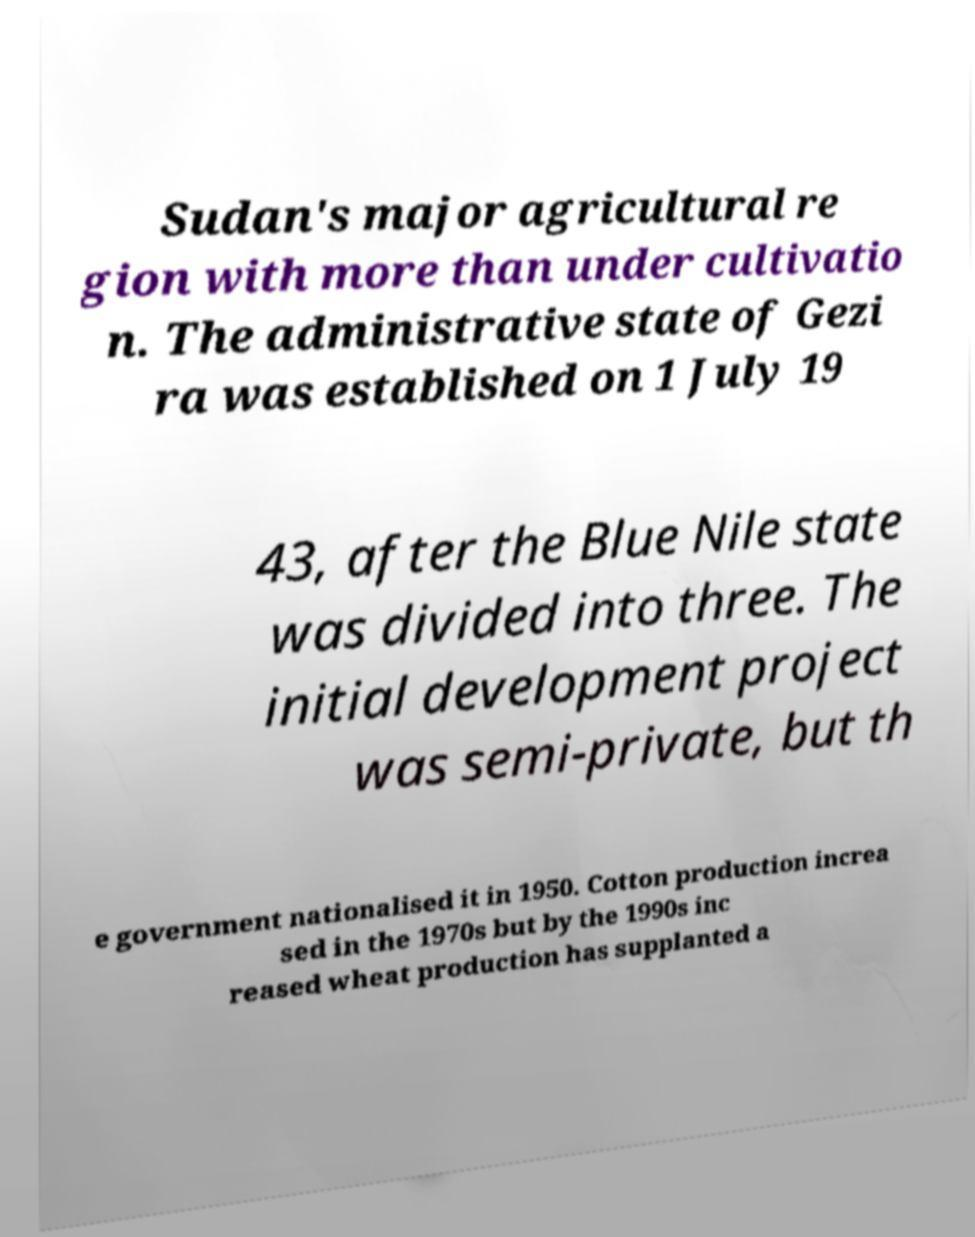There's text embedded in this image that I need extracted. Can you transcribe it verbatim? Sudan's major agricultural re gion with more than under cultivatio n. The administrative state of Gezi ra was established on 1 July 19 43, after the Blue Nile state was divided into three. The initial development project was semi-private, but th e government nationalised it in 1950. Cotton production increa sed in the 1970s but by the 1990s inc reased wheat production has supplanted a 